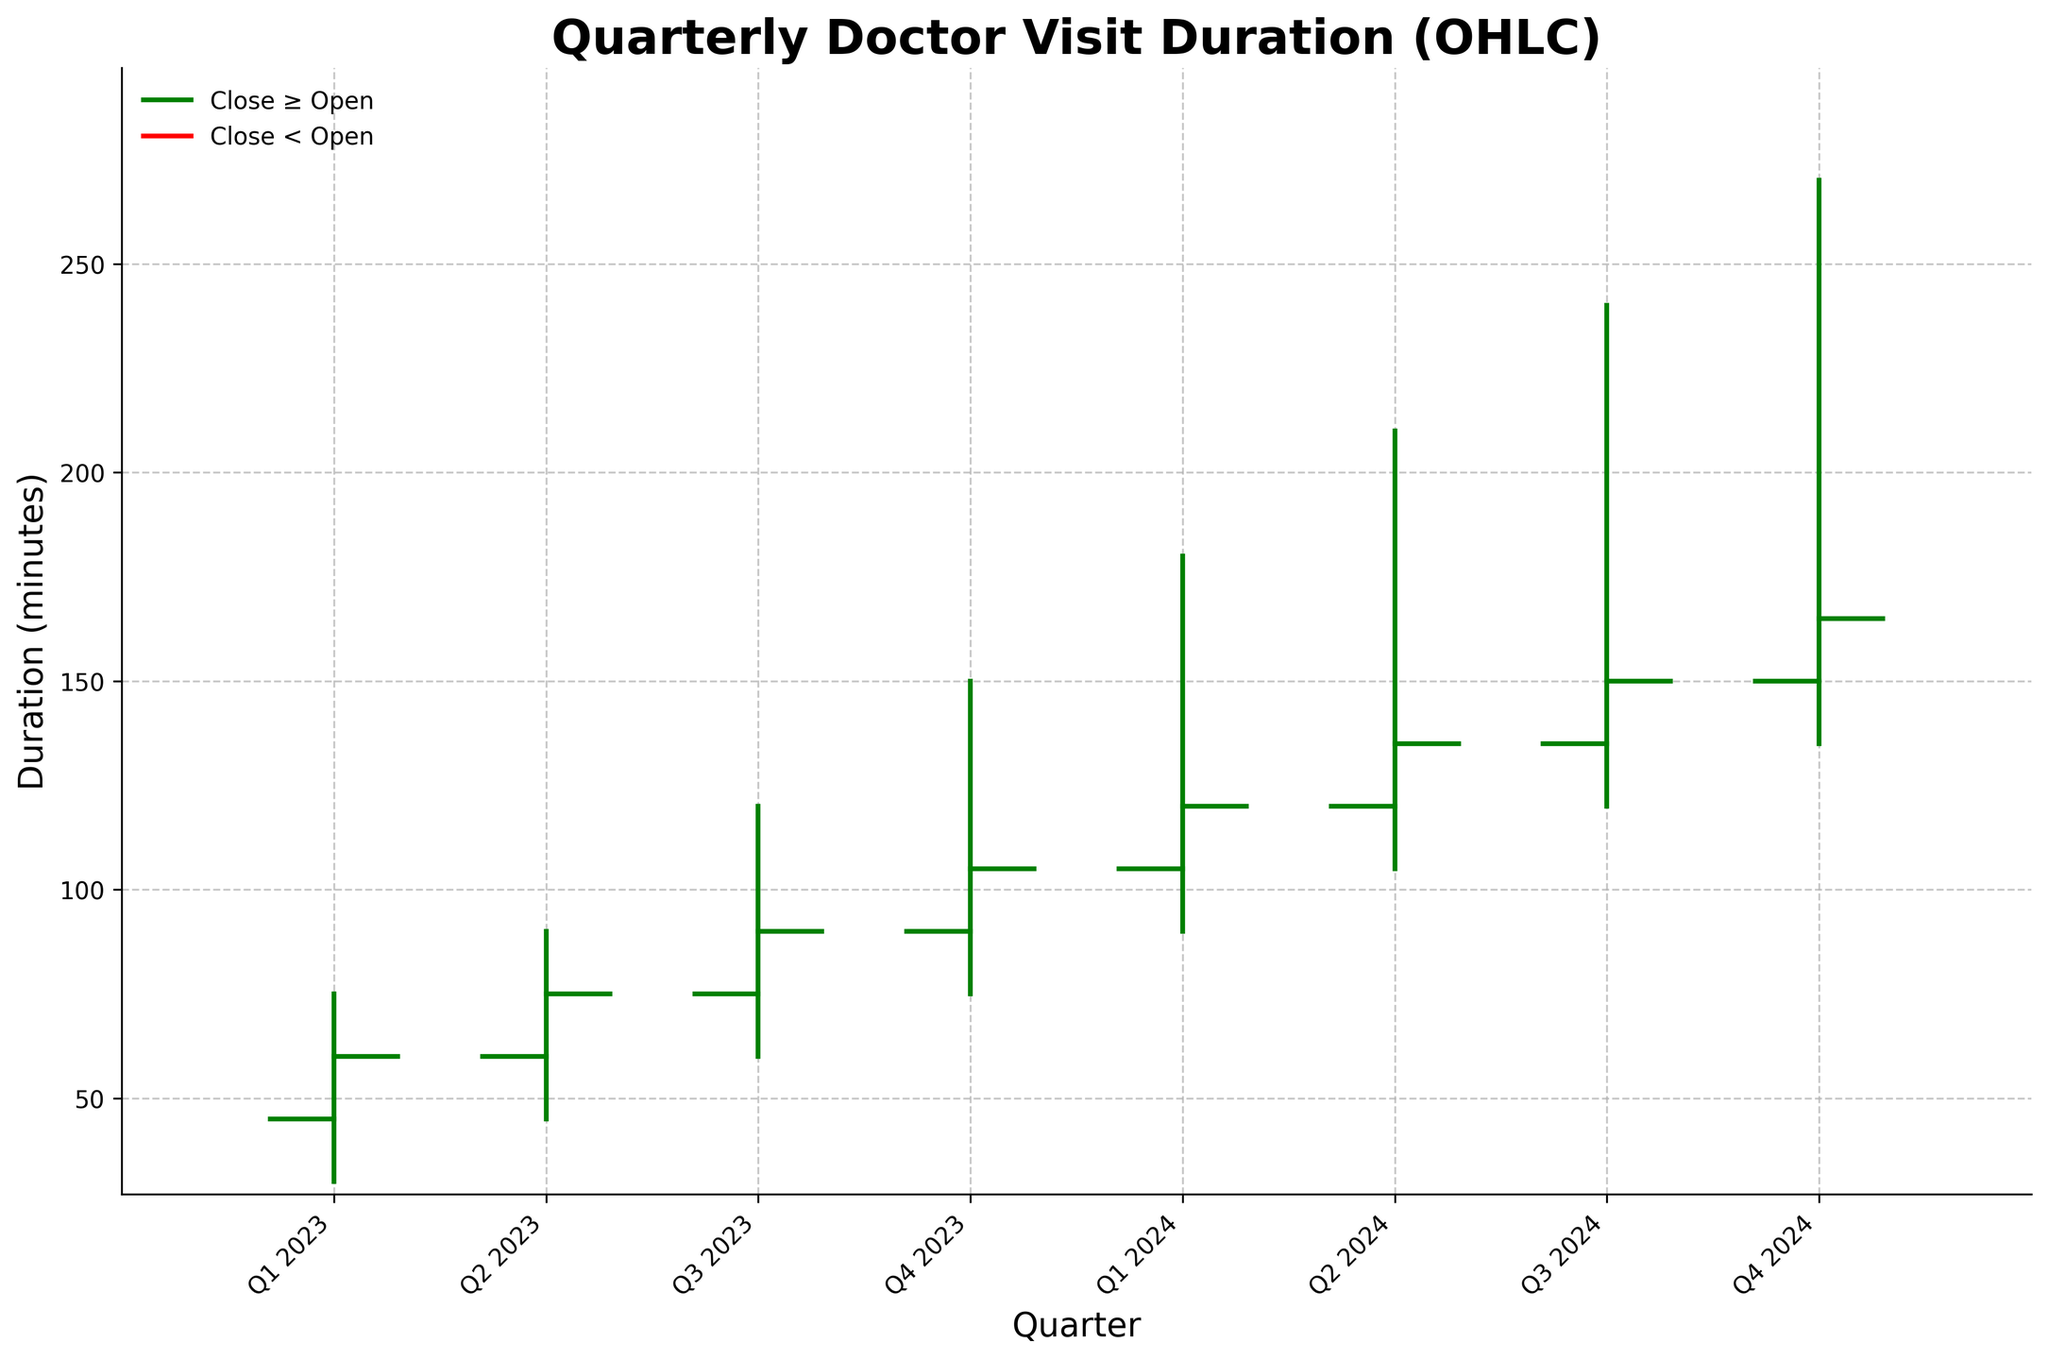what is the title of the chart? The title is located at the top of the chart and indicates the subject of the data. The title of this chart should be "Quarterly Doctor Visit Duration (OHLC)" as specified in the code.
Answer: Quarterly Doctor Visit Duration (OHLC) how many quarters are depicted in the chart? The x-axis labels enumerate the quarters. We have eight quarters starting from Q1 2023 to Q4 2024.
Answer: 8 what is the highest value in the chart and which quarter does it belong to? The highest value can be found by looking at the highest peak on the vertical lines. The highest peak is 270 minutes, which occurs in Q4 2024.
Answer: 270 minutes, Q4 2024 which quarter has the lowest "low" value and what is it? By examining the lowest points on the vertical lines, the quarter with the lowest "low" value is Q1 2023, with a value of 30 minutes.
Answer: Q1 2023, 30 minutes what is the trend of "Open" values from Q1 2023 to Q4 2024? Look at the starting point of each horizontal line on the left side. The "Open" values show an upward trend from 45 minutes in Q1 2023 to 150 minutes in Q4 2024.
Answer: Upward trend how much did the "Close" value increase from Q1 2023 to Q4 2024? The "Close" value in Q1 2023 is 60 minutes, and in Q4 2024 it is 165 minutes. The increase is 165 - 60 = 105 minutes.
Answer: 105 minutes comparing Q1 2023 with Q4 2023, which quarter has a higher "Close" value and by how much? Q1 2023 has a "Close" value of 60 minutes, and Q4 2023 has a "Close" value of 105 minutes. The difference is 105 - 60 = 45 minutes.
Answer: Q4 2023, 45 minutes which quarter has the smallest range between the "High" and "Low" values? The range is calculated as High - Low for each quarter. The smallest range is in Q2 2023 with a range of 90 - 45 = 45 minutes.
Answer: Q2 2023, 45 minutes if a patient visited the doctor in Q3 2024, what would be the "Close" value? The "Close" value is indicated by the end point of the horizontal line on the right side for Q3 2024, which is 150 minutes.
Answer: 150 minutes how does the overall duration trend between Q3 2023 and Q3 2024 compare to the trend between Q1 2023 and Q4 2023? Both the "Open" and "Close" values generally increase in both periods. However, the downward trend in the durations between these two periods is steeper in the earlier part (Q1 2023 to Q4 2023). Additionally, the absolute change for both periods can show that Q3 2023 to Q3 2024 trends higher.
Answer: Similar upward trend, steeper in earlier period 